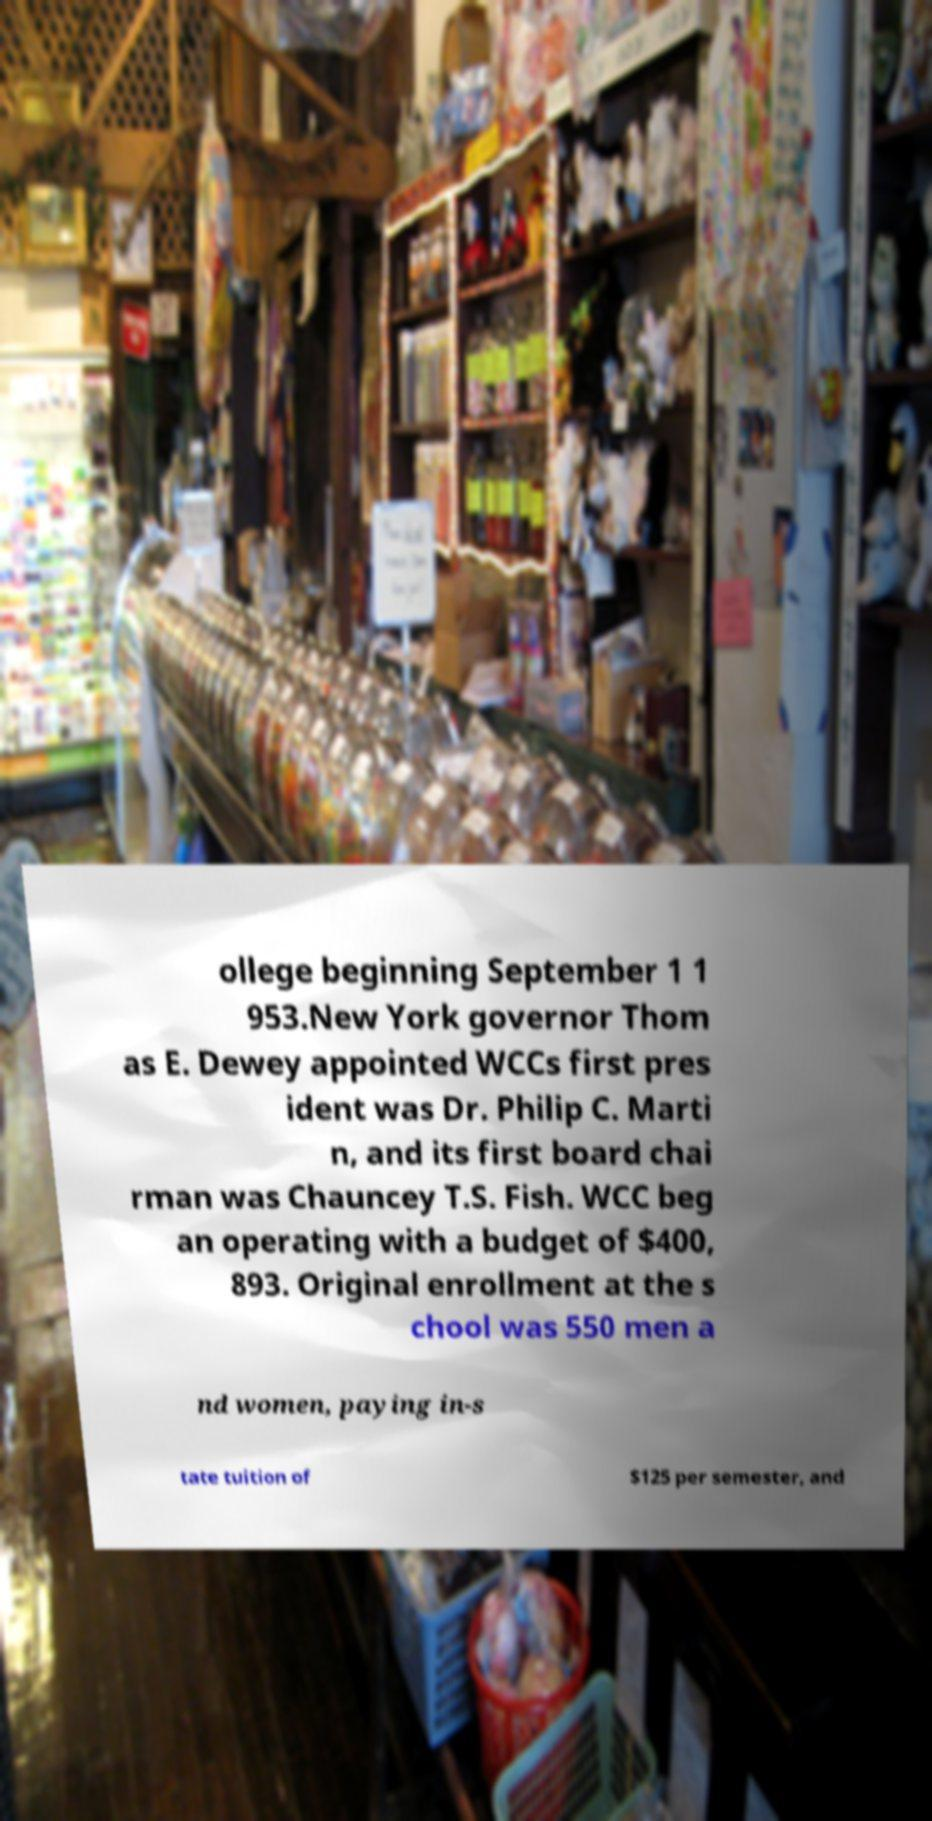I need the written content from this picture converted into text. Can you do that? ollege beginning September 1 1 953.New York governor Thom as E. Dewey appointed WCCs first pres ident was Dr. Philip C. Marti n, and its first board chai rman was Chauncey T.S. Fish. WCC beg an operating with a budget of $400, 893. Original enrollment at the s chool was 550 men a nd women, paying in-s tate tuition of $125 per semester, and 